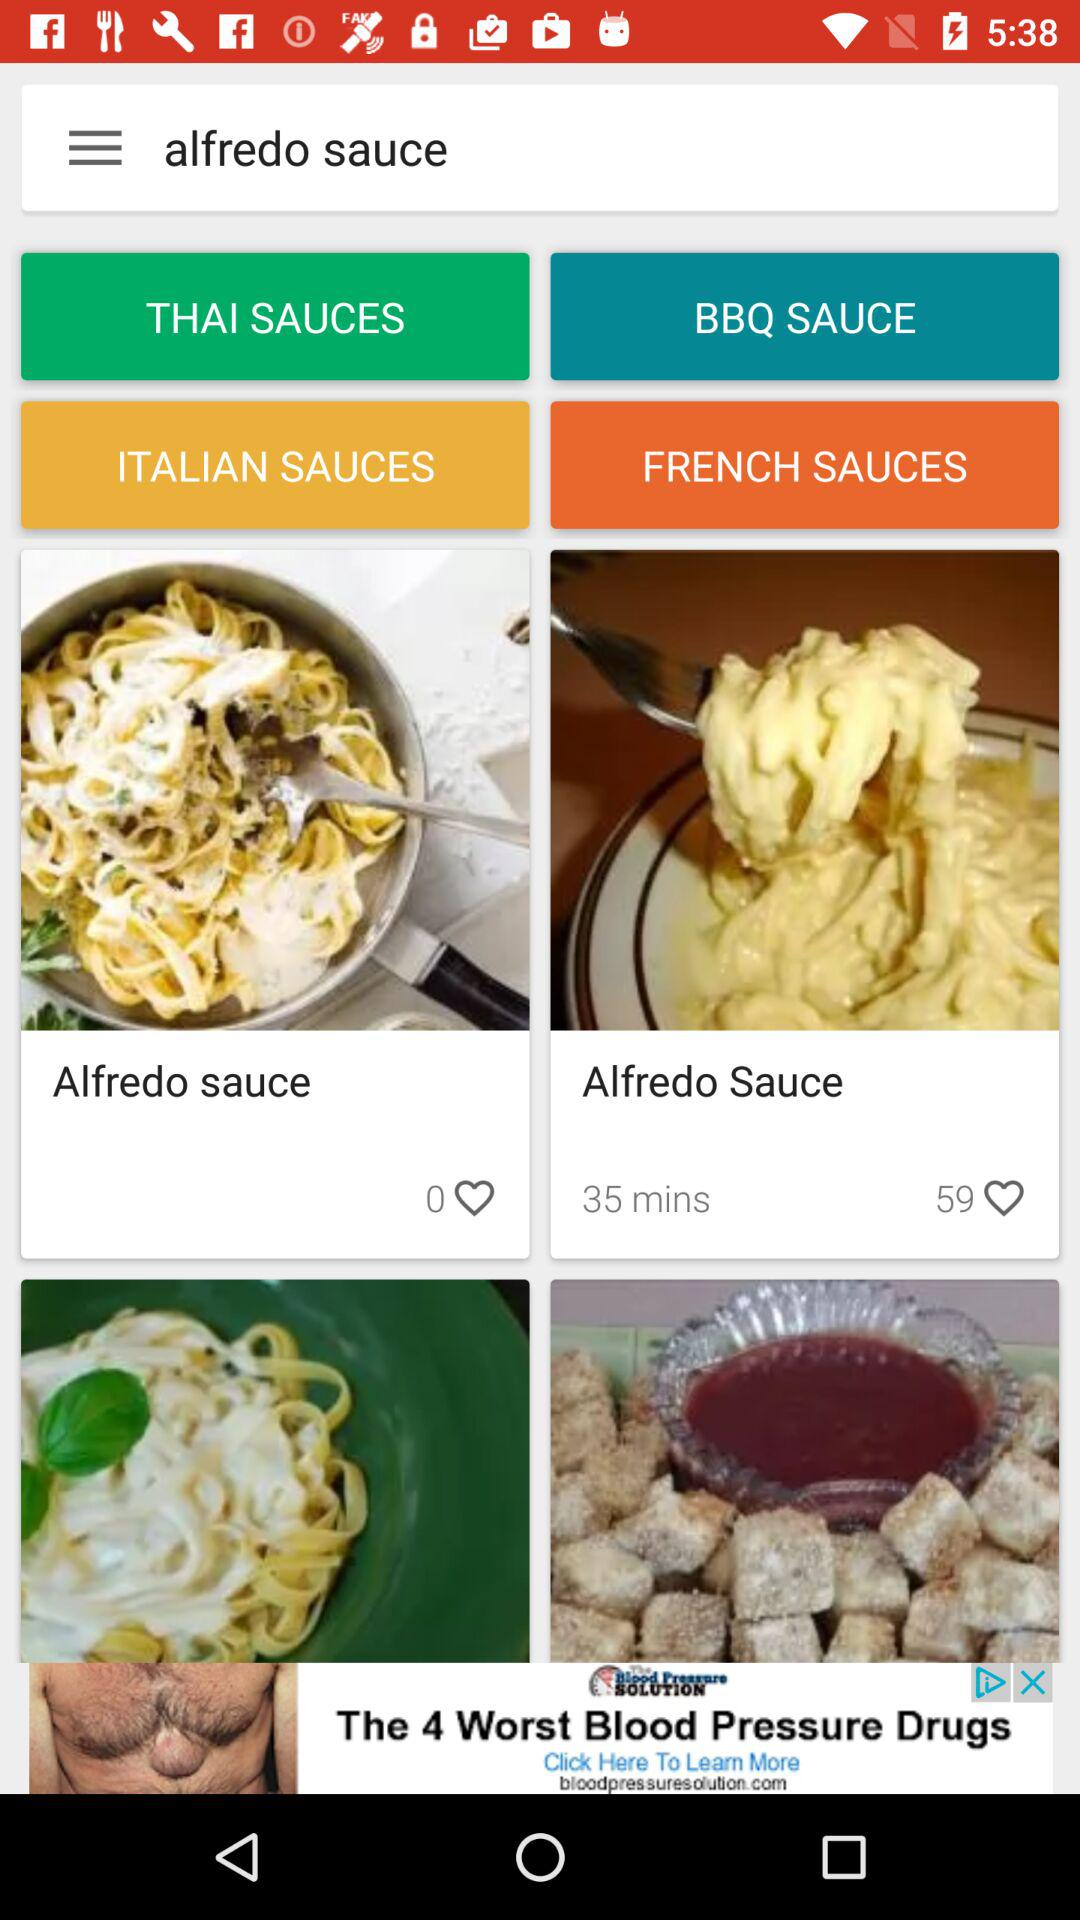How many people liked "Alfredo Sauce"? "Alfredo Sauce" is liked by 59 people. 